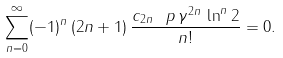<formula> <loc_0><loc_0><loc_500><loc_500>\sum _ { n = 0 } ^ { \infty } ( - 1 ) ^ { n } \, ( 2 n + 1 ) \, \frac { c _ { 2 n } \ p \, \gamma ^ { 2 n } \, \ln ^ { n } 2 } { n ! } = 0 .</formula> 